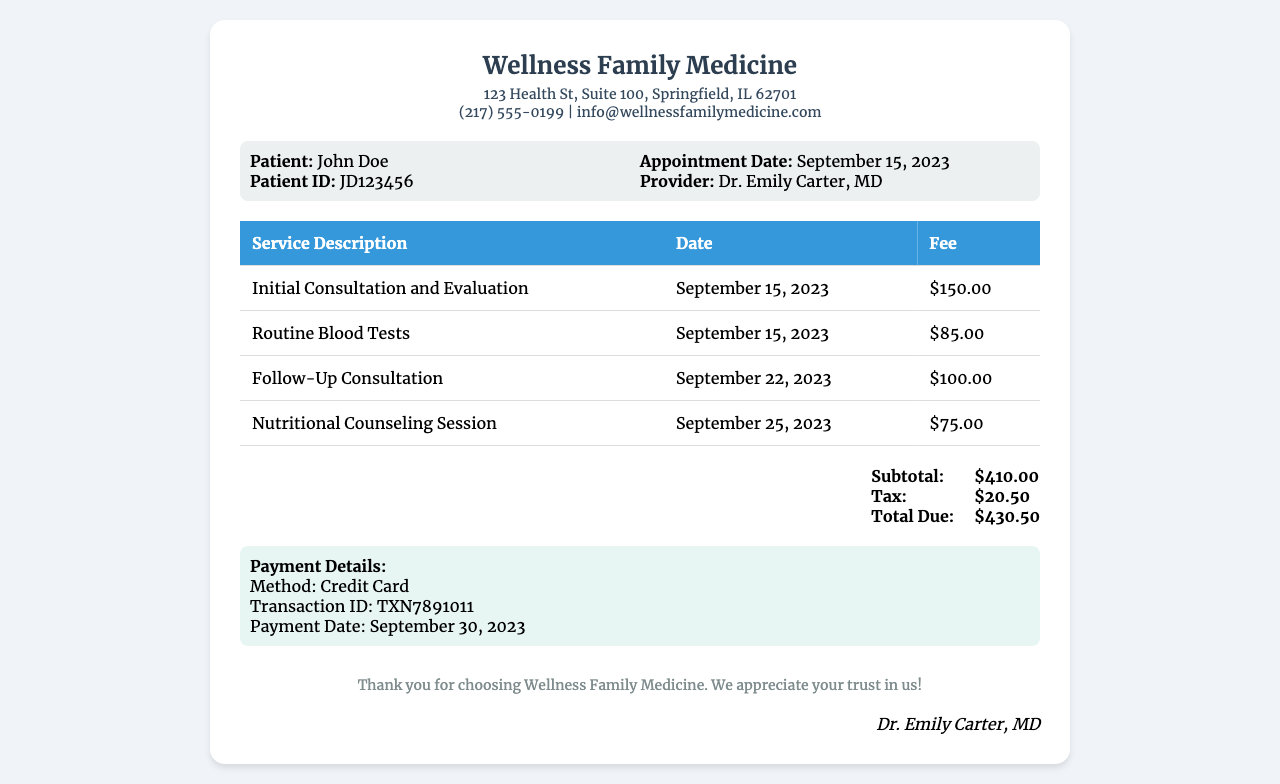What is the name of the clinic? The clinic's name is mentioned in the header of the receipt.
Answer: Wellness Family Medicine Who is the provider of the services? The provider's name is listed next to the appointment details.
Answer: Dr. Emily Carter, MD What was the date of the appointment? The appointment date is specified in the patient information section.
Answer: September 15, 2023 How much was charged for the initial consultation? The fee for the initial consultation is listed in the itemized services table.
Answer: $150.00 What is the total amount due? The total due is clearly stated in the total section of the receipt.
Answer: $430.50 What method of payment was used? The payment method is mentioned in the payment details section.
Answer: Credit Card How many services were provided in total? The number of services is based on the rows present in the itemized services table.
Answer: 4 When was the follow-up consultation date? The date for the follow-up consultation is provided in the table of services.
Answer: September 22, 2023 What is the subtotal before tax? The subtotal is listed before the tax in the total section.
Answer: $410.00 